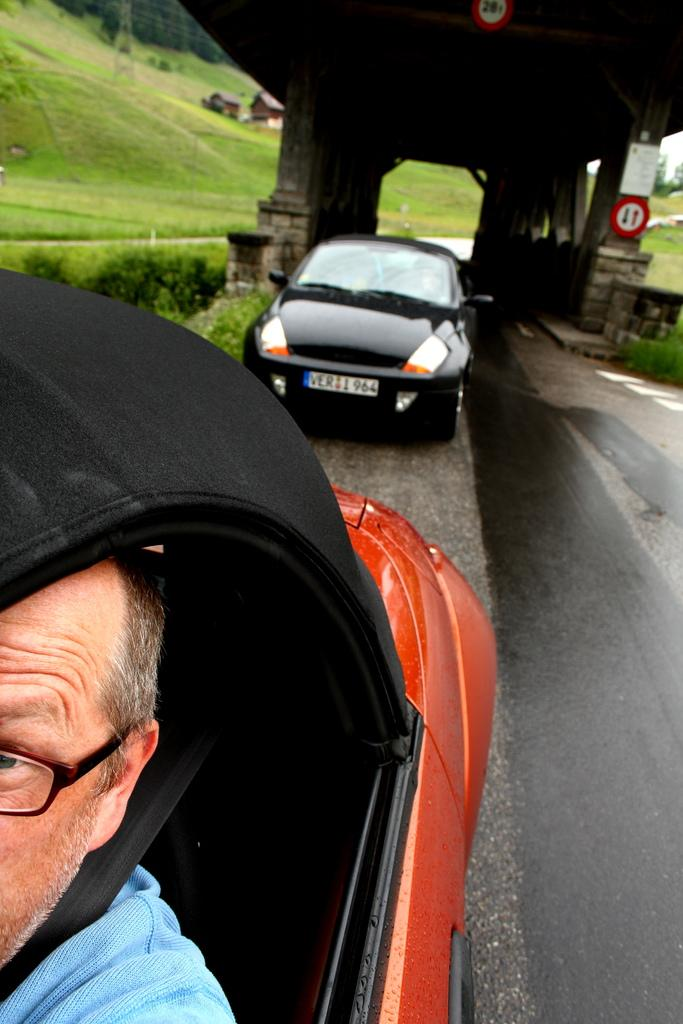What is the main subject in the foreground of the image? There is a car in the foreground of the image. Can you describe the car in the image? The car is black in color, and one person is sitting in it. What type of vegetation can be seen in the image? Grass is present in the image. Can you tell me how many ducks are joining the person in the car in the image? There are no ducks present in the image, and therefore no such interaction can be observed. 